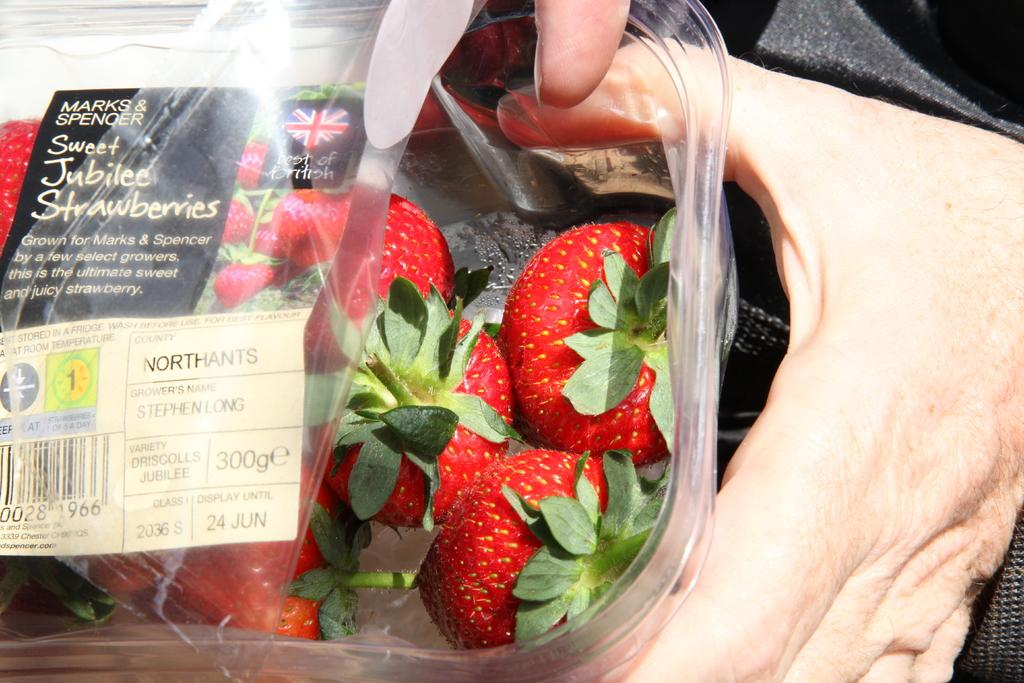Who is present in the image? There is a person in the image. What is the person holding in the image? The person is holding a box. What is inside the box? The box contains strawberries. How is the box sealed or protected? There is a cover on top of the box. What information is provided on the cover of the box? The cover has a label on it. What type of sand can be seen in the image? There is no sand present in the image. How many quivers are visible in the image? There are no quivers present in the image. 